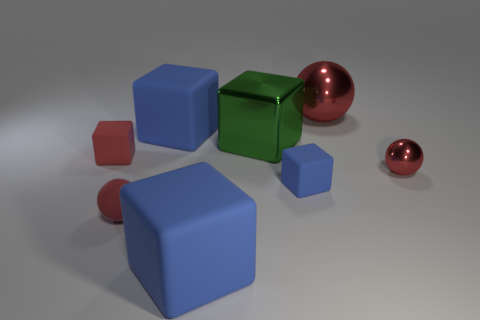How many blue cubes must be subtracted to get 1 blue cubes? 2 Subtract all large red metallic spheres. How many spheres are left? 2 Add 2 red shiny objects. How many objects exist? 10 Subtract all green cubes. How many cubes are left? 4 Subtract all blocks. How many objects are left? 3 Subtract 4 cubes. How many cubes are left? 1 Subtract all yellow blocks. Subtract all red balls. How many blocks are left? 5 Subtract all blue spheres. How many green cubes are left? 1 Subtract all large purple rubber cubes. Subtract all tiny blue rubber objects. How many objects are left? 7 Add 5 large blue objects. How many large blue objects are left? 7 